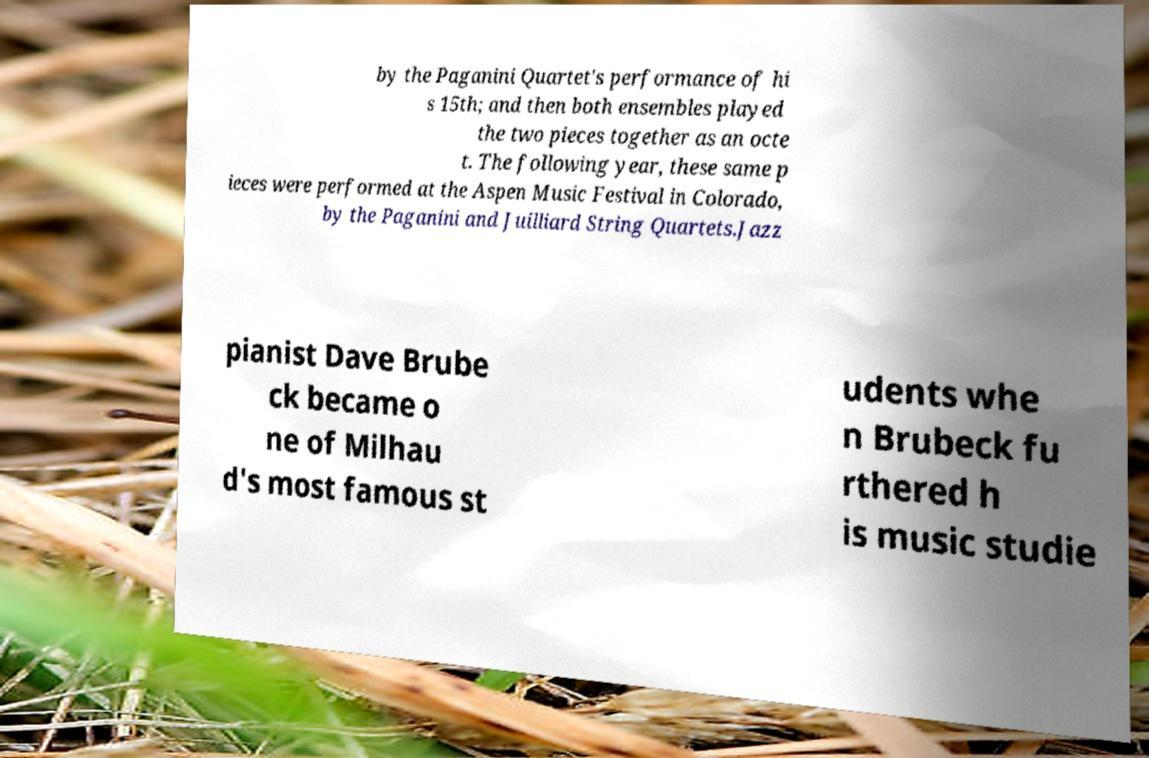What messages or text are displayed in this image? I need them in a readable, typed format. by the Paganini Quartet's performance of hi s 15th; and then both ensembles played the two pieces together as an octe t. The following year, these same p ieces were performed at the Aspen Music Festival in Colorado, by the Paganini and Juilliard String Quartets.Jazz pianist Dave Brube ck became o ne of Milhau d's most famous st udents whe n Brubeck fu rthered h is music studie 